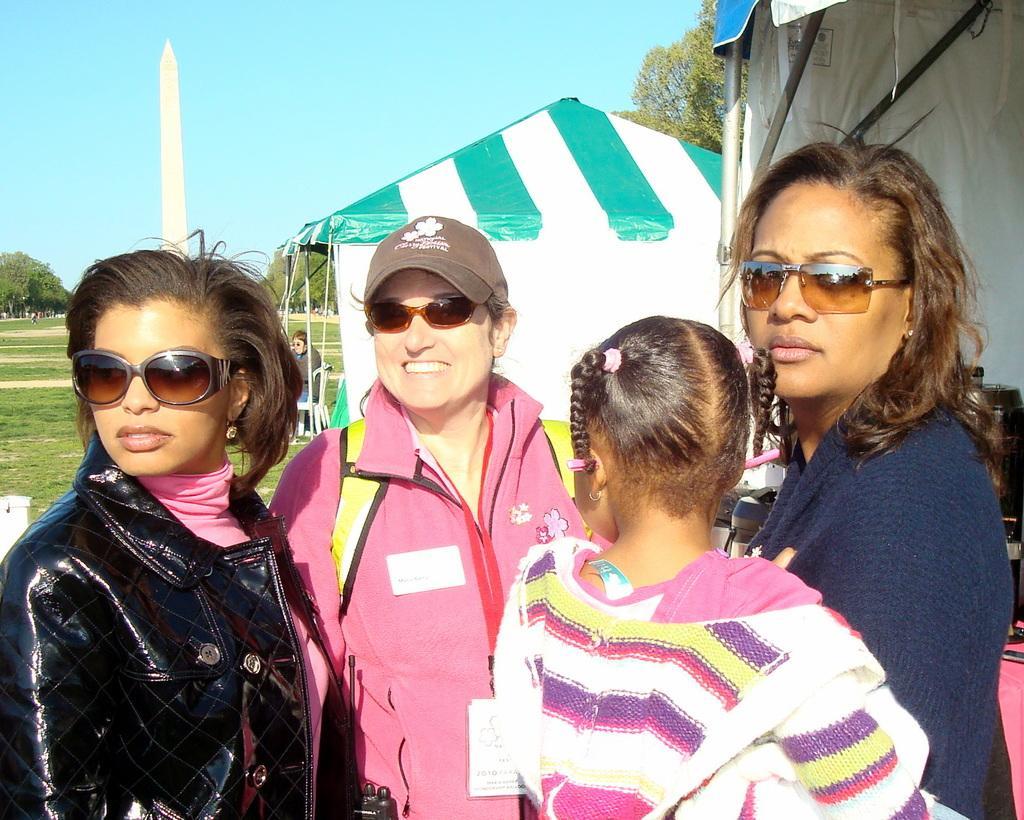Could you give a brief overview of what you see in this image? In this image there are three women wearing glasses and one woman holding a girl. In the background there are tents for shelter and there are trees. There is also a person sitting on the chair. White pole and grass is visible. At the top there is sky. 